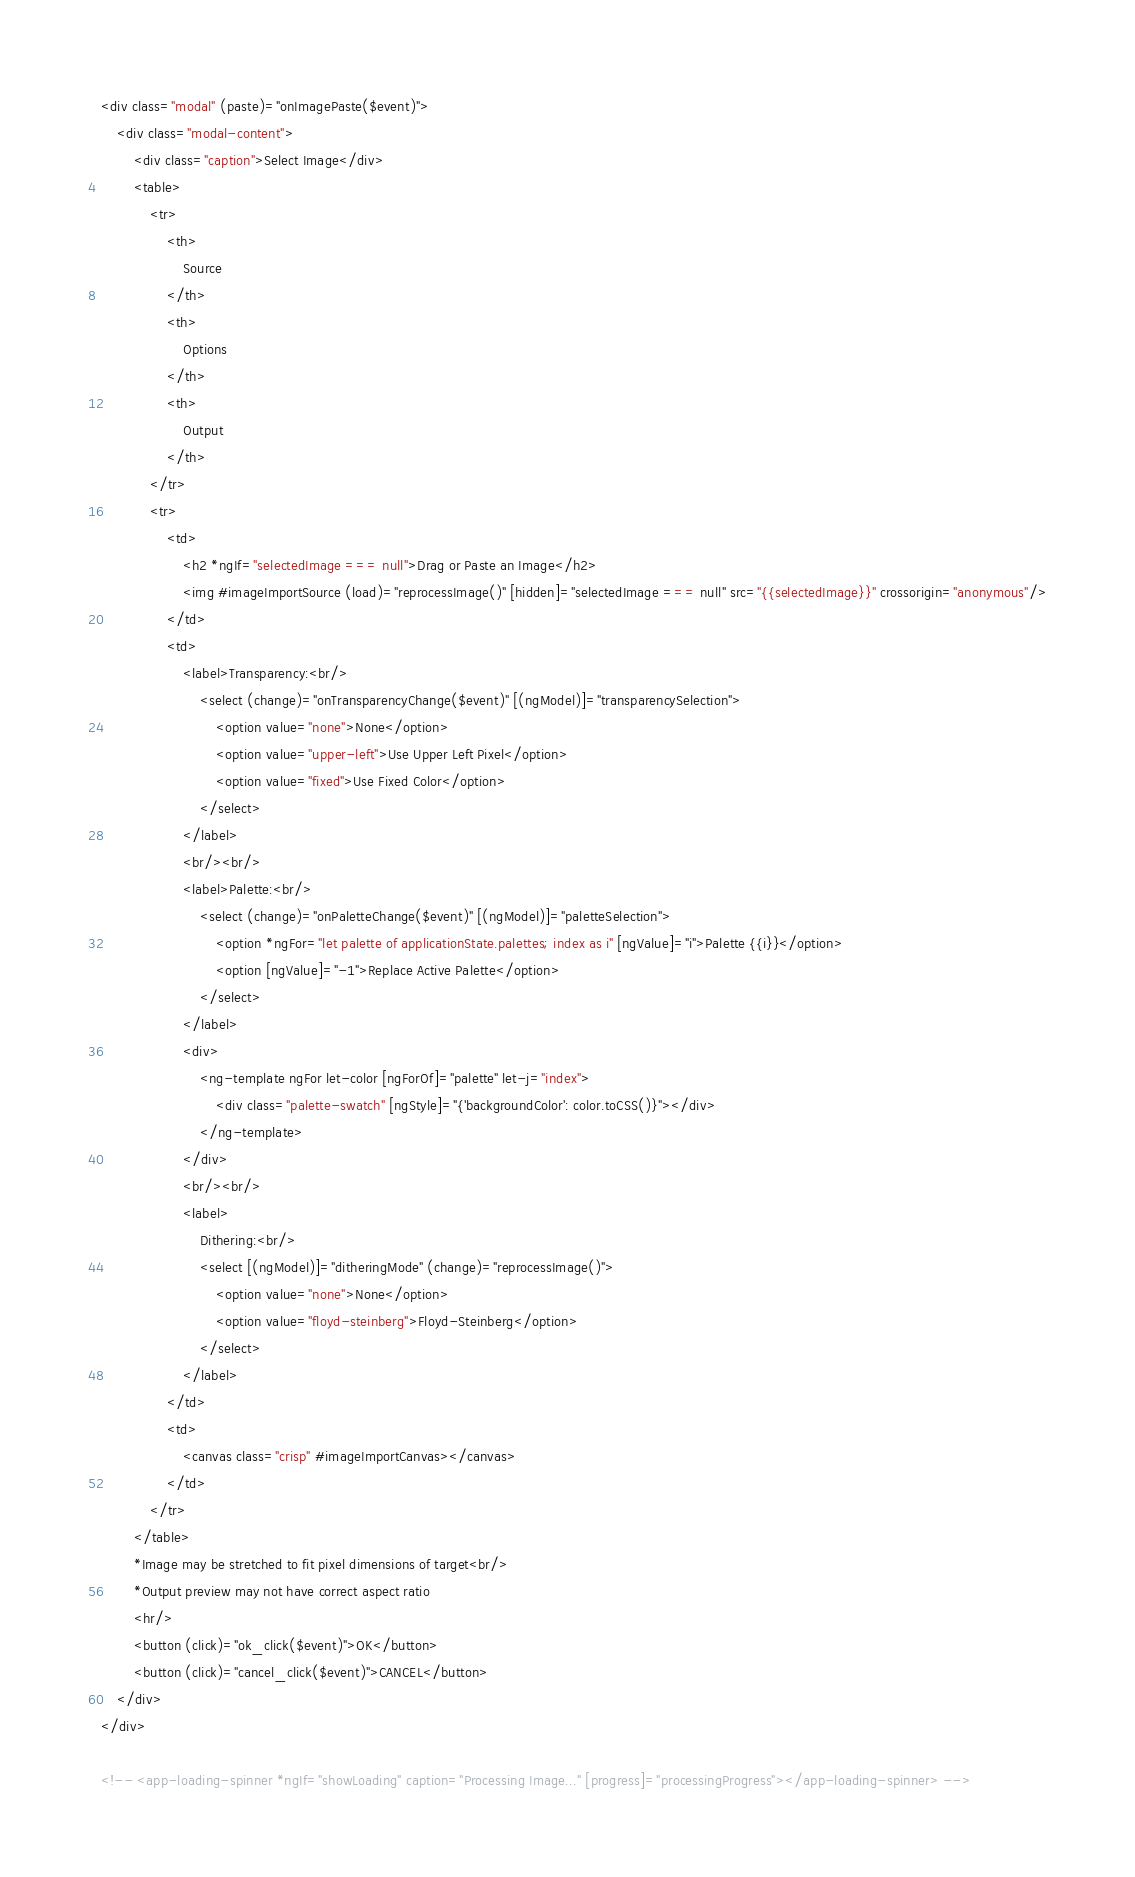<code> <loc_0><loc_0><loc_500><loc_500><_HTML_><div class="modal" (paste)="onImagePaste($event)">
    <div class="modal-content">
        <div class="caption">Select Image</div>
        <table>
            <tr>
                <th>
                    Source
                </th>
                <th>
                    Options
                </th>
                <th>
                    Output
                </th>
            </tr>
            <tr>
                <td>
                    <h2 *ngIf="selectedImage === null">Drag or Paste an Image</h2>
                    <img #imageImportSource (load)="reprocessImage()" [hidden]="selectedImage === null" src="{{selectedImage}}" crossorigin="anonymous"/>
                </td>
                <td>
                    <label>Transparency:<br/>
                        <select (change)="onTransparencyChange($event)" [(ngModel)]="transparencySelection">
                            <option value="none">None</option>
                            <option value="upper-left">Use Upper Left Pixel</option>
                            <option value="fixed">Use Fixed Color</option>
                        </select>
                    </label>
                    <br/><br/>
                    <label>Palette:<br/>
                        <select (change)="onPaletteChange($event)" [(ngModel)]="paletteSelection">
                            <option *ngFor="let palette of applicationState.palettes; index as i" [ngValue]="i">Palette {{i}}</option>
                            <option [ngValue]="-1">Replace Active Palette</option>
                        </select>
                    </label>
                    <div>
                        <ng-template ngFor let-color [ngForOf]="palette" let-j="index">
                            <div class="palette-swatch" [ngStyle]="{'backgroundColor': color.toCSS()}"></div>
                        </ng-template>
                    </div>
                    <br/><br/>
                    <label>
                        Dithering:<br/>
                        <select [(ngModel)]="ditheringMode" (change)="reprocessImage()">
                            <option value="none">None</option>
                            <option value="floyd-steinberg">Floyd-Steinberg</option>
                        </select>
                    </label>
                </td>
                <td>
                    <canvas class="crisp" #imageImportCanvas></canvas>
                </td>
            </tr>
        </table>
        *Image may be stretched to fit pixel dimensions of target<br/>
        *Output preview may not have correct aspect ratio
        <hr/>
        <button (click)="ok_click($event)">OK</button>
        <button (click)="cancel_click($event)">CANCEL</button>
    </div>
</div>

<!-- <app-loading-spinner *ngIf="showLoading" caption="Processing Image..." [progress]="processingProgress"></app-loading-spinner> --></code> 